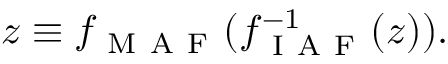Convert formula to latex. <formula><loc_0><loc_0><loc_500><loc_500>z \equiv f _ { M A F } ( f _ { I A F } ^ { - 1 } ( z ) ) .</formula> 